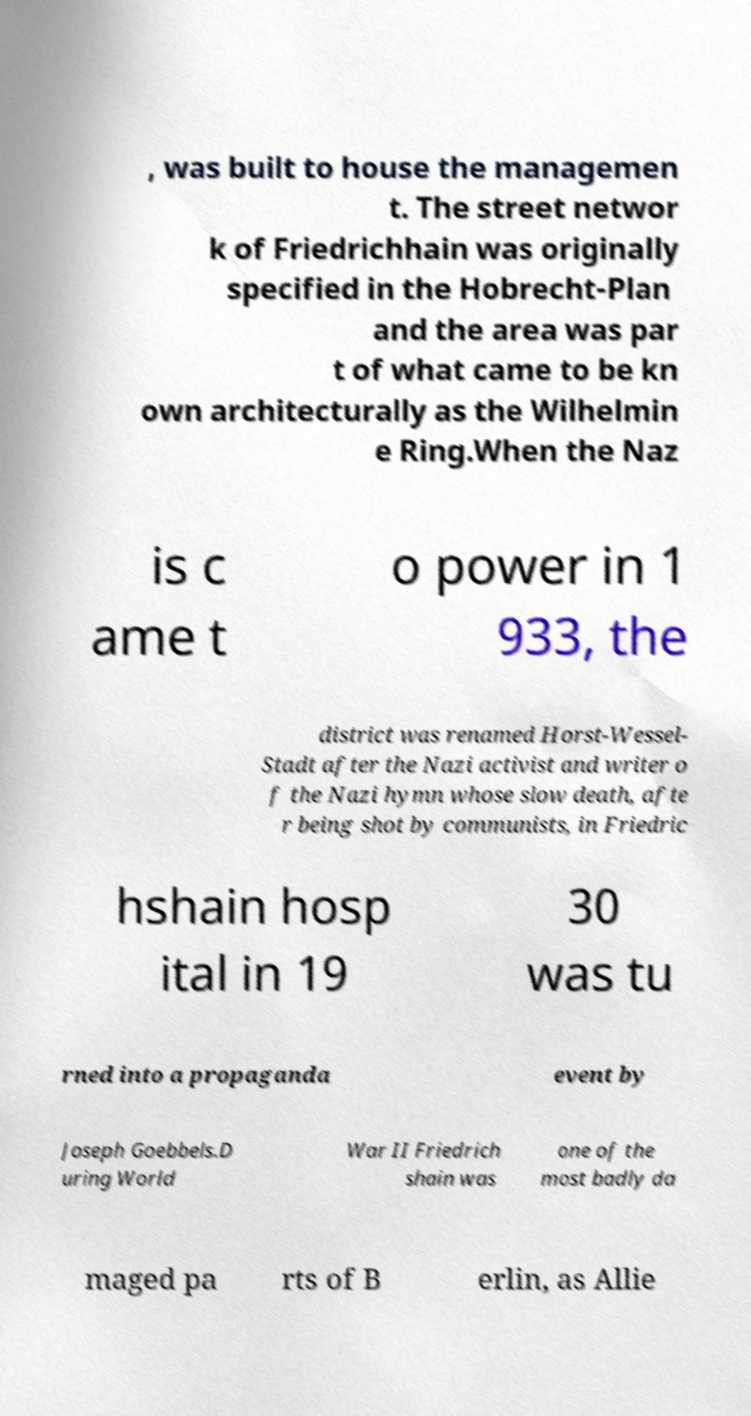Could you assist in decoding the text presented in this image and type it out clearly? , was built to house the managemen t. The street networ k of Friedrichhain was originally specified in the Hobrecht-Plan and the area was par t of what came to be kn own architecturally as the Wilhelmin e Ring.When the Naz is c ame t o power in 1 933, the district was renamed Horst-Wessel- Stadt after the Nazi activist and writer o f the Nazi hymn whose slow death, afte r being shot by communists, in Friedric hshain hosp ital in 19 30 was tu rned into a propaganda event by Joseph Goebbels.D uring World War II Friedrich shain was one of the most badly da maged pa rts of B erlin, as Allie 